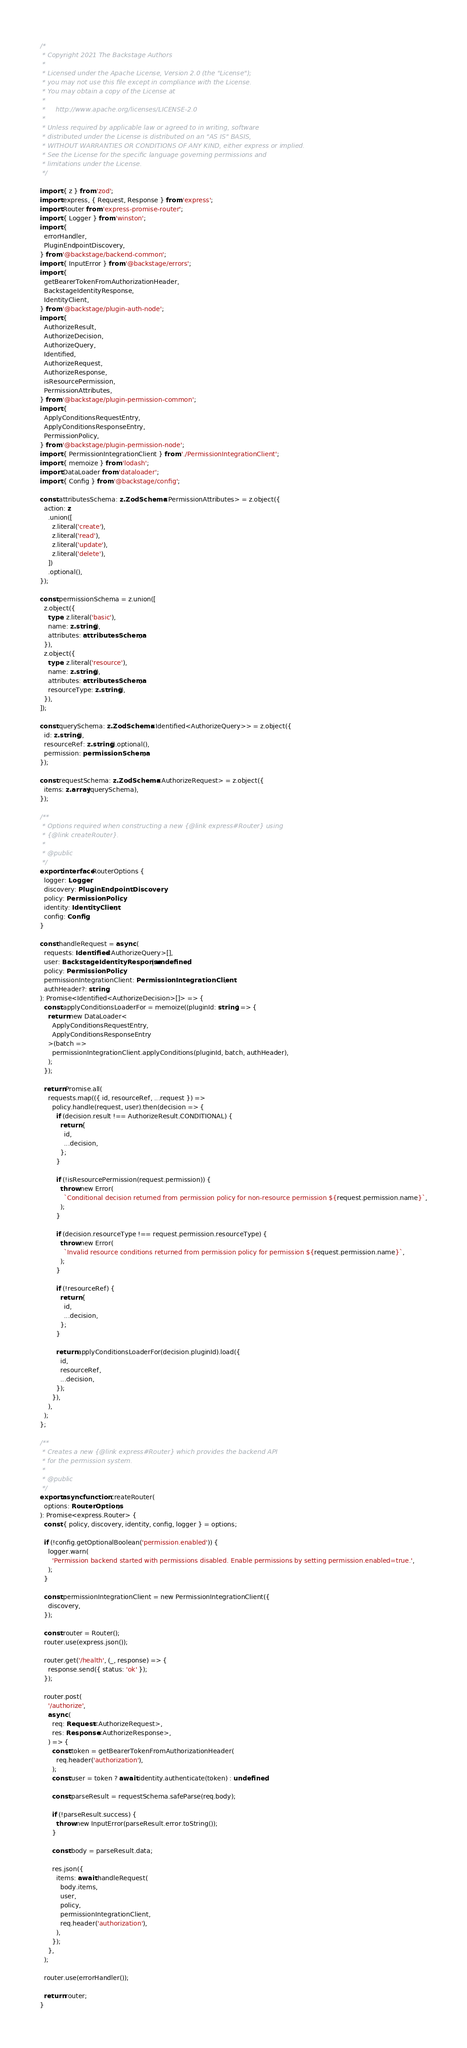<code> <loc_0><loc_0><loc_500><loc_500><_TypeScript_>/*
 * Copyright 2021 The Backstage Authors
 *
 * Licensed under the Apache License, Version 2.0 (the "License");
 * you may not use this file except in compliance with the License.
 * You may obtain a copy of the License at
 *
 *     http://www.apache.org/licenses/LICENSE-2.0
 *
 * Unless required by applicable law or agreed to in writing, software
 * distributed under the License is distributed on an "AS IS" BASIS,
 * WITHOUT WARRANTIES OR CONDITIONS OF ANY KIND, either express or implied.
 * See the License for the specific language governing permissions and
 * limitations under the License.
 */

import { z } from 'zod';
import express, { Request, Response } from 'express';
import Router from 'express-promise-router';
import { Logger } from 'winston';
import {
  errorHandler,
  PluginEndpointDiscovery,
} from '@backstage/backend-common';
import { InputError } from '@backstage/errors';
import {
  getBearerTokenFromAuthorizationHeader,
  BackstageIdentityResponse,
  IdentityClient,
} from '@backstage/plugin-auth-node';
import {
  AuthorizeResult,
  AuthorizeDecision,
  AuthorizeQuery,
  Identified,
  AuthorizeRequest,
  AuthorizeResponse,
  isResourcePermission,
  PermissionAttributes,
} from '@backstage/plugin-permission-common';
import {
  ApplyConditionsRequestEntry,
  ApplyConditionsResponseEntry,
  PermissionPolicy,
} from '@backstage/plugin-permission-node';
import { PermissionIntegrationClient } from './PermissionIntegrationClient';
import { memoize } from 'lodash';
import DataLoader from 'dataloader';
import { Config } from '@backstage/config';

const attributesSchema: z.ZodSchema<PermissionAttributes> = z.object({
  action: z
    .union([
      z.literal('create'),
      z.literal('read'),
      z.literal('update'),
      z.literal('delete'),
    ])
    .optional(),
});

const permissionSchema = z.union([
  z.object({
    type: z.literal('basic'),
    name: z.string(),
    attributes: attributesSchema,
  }),
  z.object({
    type: z.literal('resource'),
    name: z.string(),
    attributes: attributesSchema,
    resourceType: z.string(),
  }),
]);

const querySchema: z.ZodSchema<Identified<AuthorizeQuery>> = z.object({
  id: z.string(),
  resourceRef: z.string().optional(),
  permission: permissionSchema,
});

const requestSchema: z.ZodSchema<AuthorizeRequest> = z.object({
  items: z.array(querySchema),
});

/**
 * Options required when constructing a new {@link express#Router} using
 * {@link createRouter}.
 *
 * @public
 */
export interface RouterOptions {
  logger: Logger;
  discovery: PluginEndpointDiscovery;
  policy: PermissionPolicy;
  identity: IdentityClient;
  config: Config;
}

const handleRequest = async (
  requests: Identified<AuthorizeQuery>[],
  user: BackstageIdentityResponse | undefined,
  policy: PermissionPolicy,
  permissionIntegrationClient: PermissionIntegrationClient,
  authHeader?: string,
): Promise<Identified<AuthorizeDecision>[]> => {
  const applyConditionsLoaderFor = memoize((pluginId: string) => {
    return new DataLoader<
      ApplyConditionsRequestEntry,
      ApplyConditionsResponseEntry
    >(batch =>
      permissionIntegrationClient.applyConditions(pluginId, batch, authHeader),
    );
  });

  return Promise.all(
    requests.map(({ id, resourceRef, ...request }) =>
      policy.handle(request, user).then(decision => {
        if (decision.result !== AuthorizeResult.CONDITIONAL) {
          return {
            id,
            ...decision,
          };
        }

        if (!isResourcePermission(request.permission)) {
          throw new Error(
            `Conditional decision returned from permission policy for non-resource permission ${request.permission.name}`,
          );
        }

        if (decision.resourceType !== request.permission.resourceType) {
          throw new Error(
            `Invalid resource conditions returned from permission policy for permission ${request.permission.name}`,
          );
        }

        if (!resourceRef) {
          return {
            id,
            ...decision,
          };
        }

        return applyConditionsLoaderFor(decision.pluginId).load({
          id,
          resourceRef,
          ...decision,
        });
      }),
    ),
  );
};

/**
 * Creates a new {@link express#Router} which provides the backend API
 * for the permission system.
 *
 * @public
 */
export async function createRouter(
  options: RouterOptions,
): Promise<express.Router> {
  const { policy, discovery, identity, config, logger } = options;

  if (!config.getOptionalBoolean('permission.enabled')) {
    logger.warn(
      'Permission backend started with permissions disabled. Enable permissions by setting permission.enabled=true.',
    );
  }

  const permissionIntegrationClient = new PermissionIntegrationClient({
    discovery,
  });

  const router = Router();
  router.use(express.json());

  router.get('/health', (_, response) => {
    response.send({ status: 'ok' });
  });

  router.post(
    '/authorize',
    async (
      req: Request<AuthorizeRequest>,
      res: Response<AuthorizeResponse>,
    ) => {
      const token = getBearerTokenFromAuthorizationHeader(
        req.header('authorization'),
      );
      const user = token ? await identity.authenticate(token) : undefined;

      const parseResult = requestSchema.safeParse(req.body);

      if (!parseResult.success) {
        throw new InputError(parseResult.error.toString());
      }

      const body = parseResult.data;

      res.json({
        items: await handleRequest(
          body.items,
          user,
          policy,
          permissionIntegrationClient,
          req.header('authorization'),
        ),
      });
    },
  );

  router.use(errorHandler());

  return router;
}
</code> 